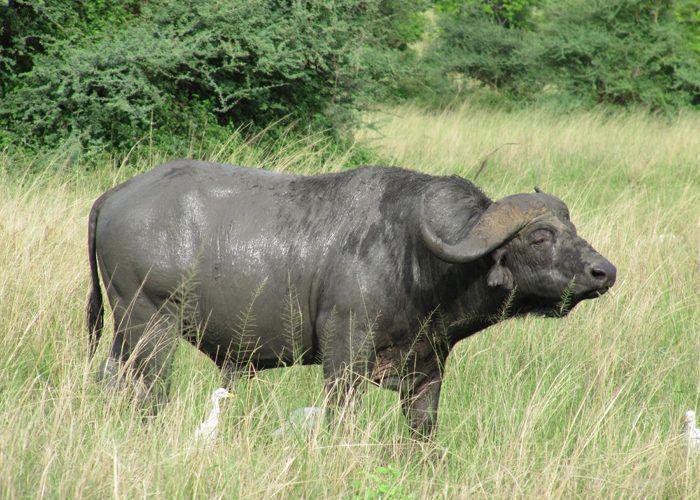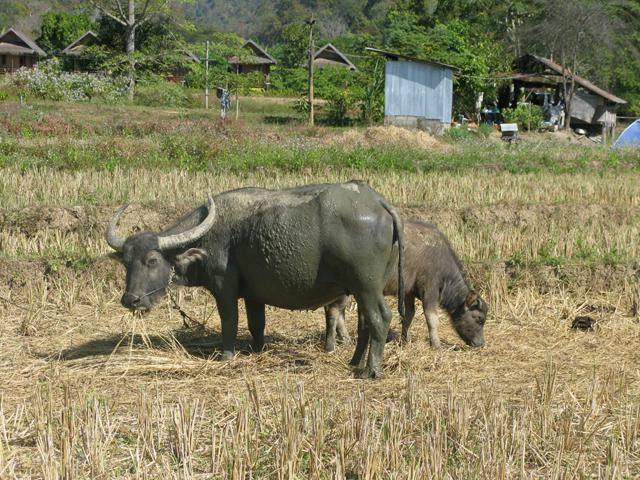The first image is the image on the left, the second image is the image on the right. Examine the images to the left and right. Is the description "The oxen in the foreground of the two images have their bodies facing each other." accurate? Answer yes or no. Yes. 